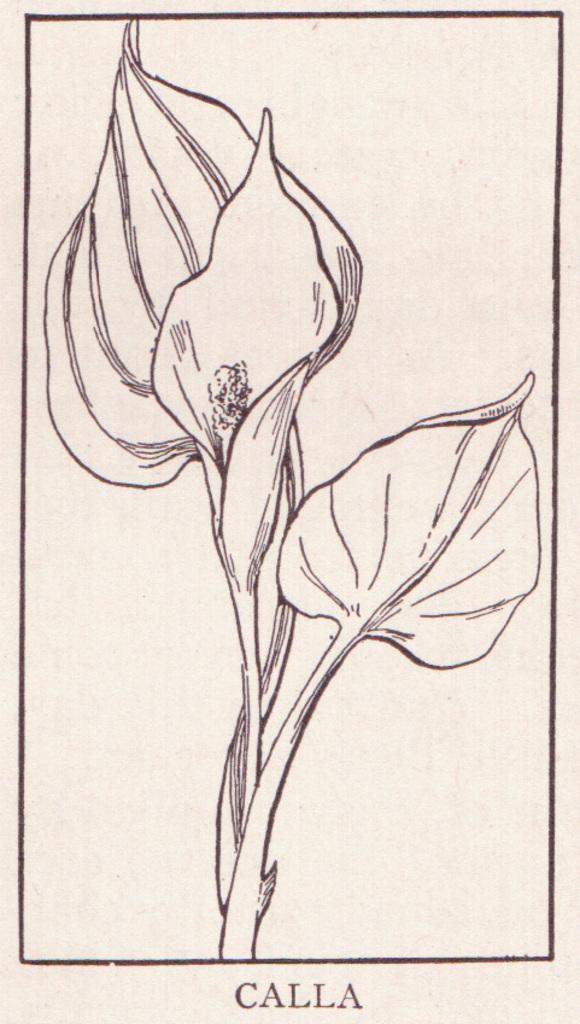What is depicted in the image? The image contains a sketch of leaves and a stem. Is there any text associated with the sketch? Yes, there is some text at the bottom of the image. What is the boy doing in the image? There is no boy present in the image; it contains a sketch of leaves and a stem with some text at the bottom. 